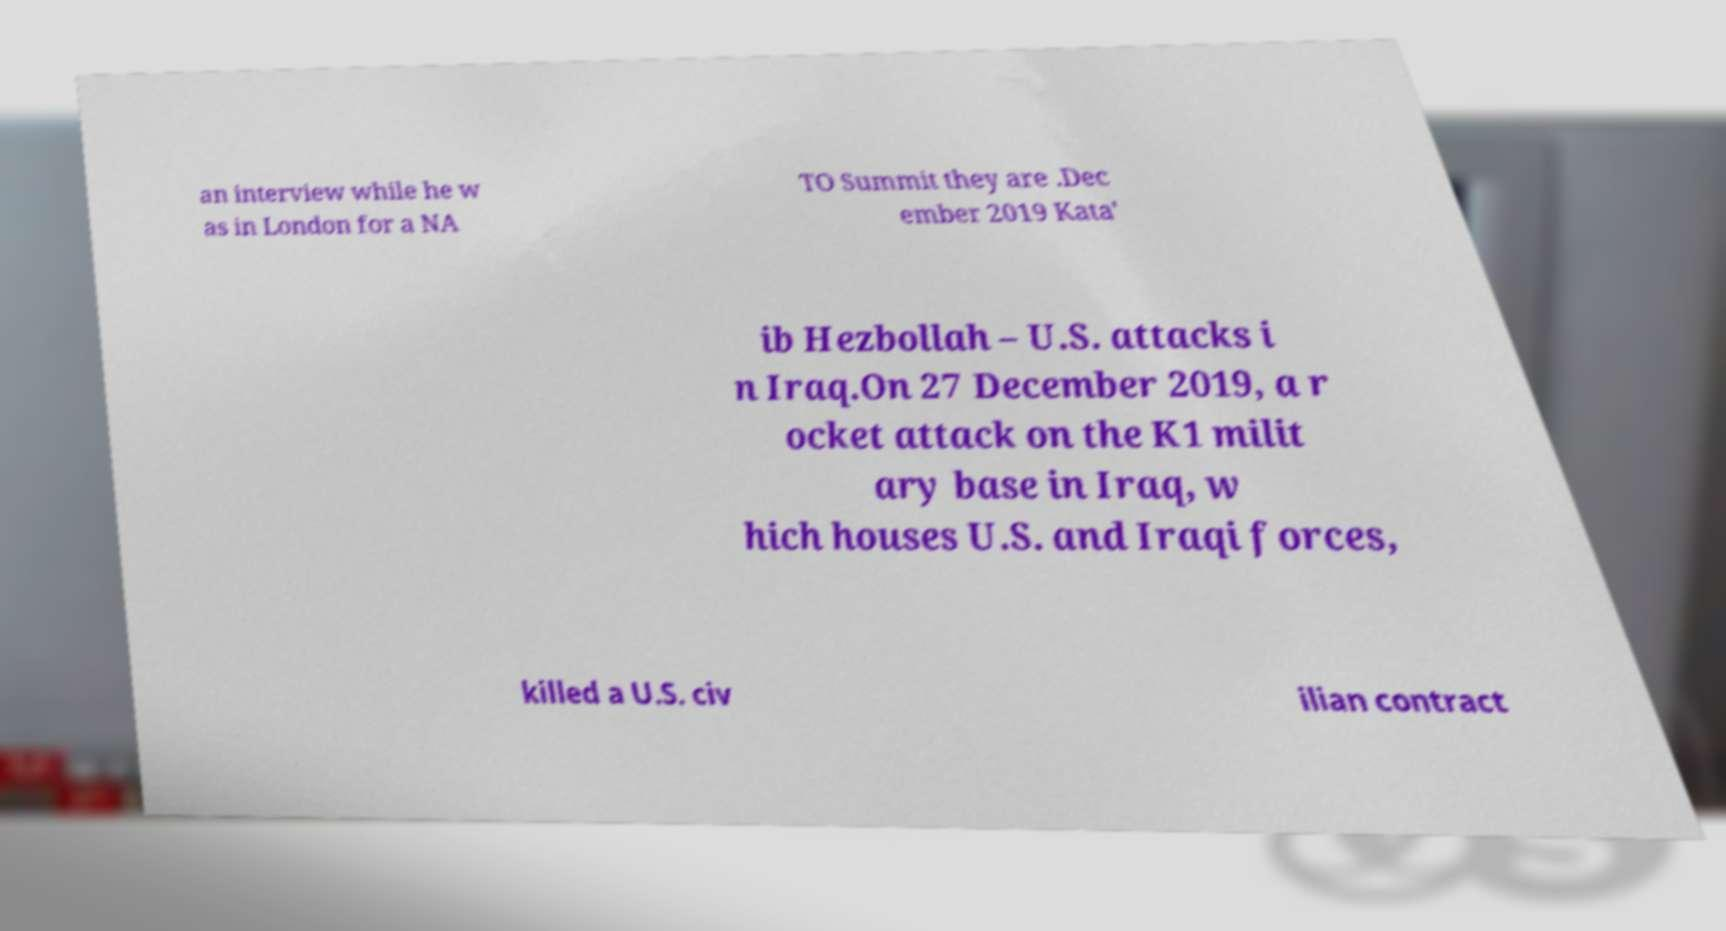Please read and relay the text visible in this image. What does it say? an interview while he w as in London for a NA TO Summit they are .Dec ember 2019 Kata' ib Hezbollah – U.S. attacks i n Iraq.On 27 December 2019, a r ocket attack on the K1 milit ary base in Iraq, w hich houses U.S. and Iraqi forces, killed a U.S. civ ilian contract 